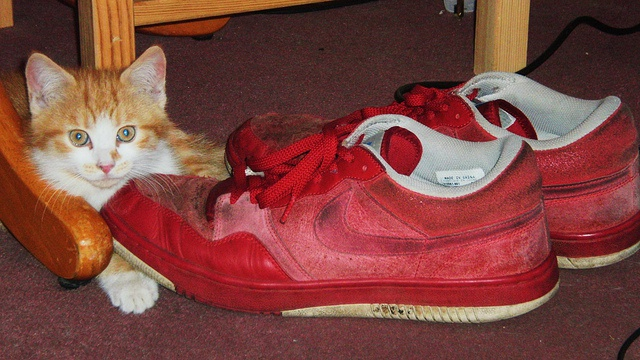Describe the objects in this image and their specific colors. I can see cat in red, tan, darkgray, lightgray, and gray tones and chair in brown, red, tan, maroon, and orange tones in this image. 